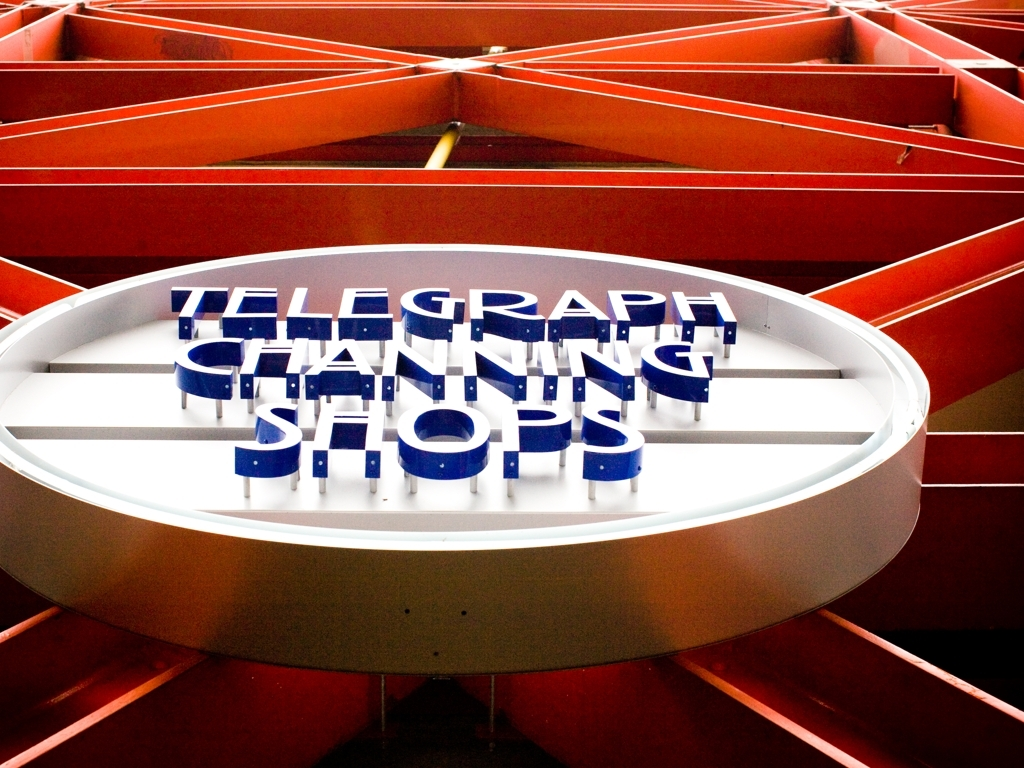How does the composition of the image contribute to its overall effect? The composition of the image, with the concentric circles and radiating lines, leads the viewer's eye toward the center where the text 'TELEGRAPH CHANNING SHOPS' is located. The use of symmetry and geometric patterns gives the image a sense of balance and order, while the warm and cool color contrast adds visual interest and dynamism. 